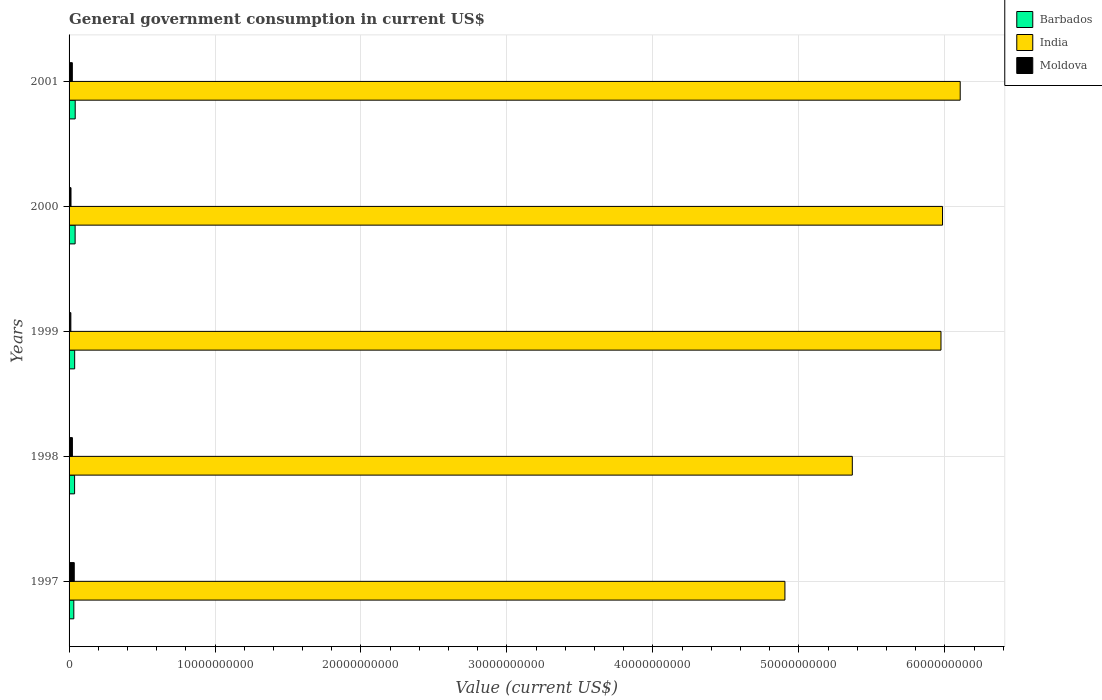How many different coloured bars are there?
Your answer should be very brief. 3. Are the number of bars on each tick of the Y-axis equal?
Make the answer very short. Yes. What is the label of the 3rd group of bars from the top?
Your response must be concise. 1999. What is the government conusmption in India in 1999?
Provide a short and direct response. 5.97e+1. Across all years, what is the maximum government conusmption in Barbados?
Make the answer very short. 4.20e+08. Across all years, what is the minimum government conusmption in Moldova?
Keep it short and to the point. 1.22e+08. In which year was the government conusmption in Moldova maximum?
Make the answer very short. 1997. In which year was the government conusmption in Moldova minimum?
Make the answer very short. 1999. What is the total government conusmption in India in the graph?
Your answer should be compact. 2.83e+11. What is the difference between the government conusmption in Barbados in 1998 and that in 2001?
Provide a short and direct response. -4.21e+07. What is the difference between the government conusmption in Moldova in 1998 and the government conusmption in Barbados in 2001?
Offer a very short reply. -1.92e+08. What is the average government conusmption in Barbados per year?
Provide a succinct answer. 3.84e+08. In the year 1999, what is the difference between the government conusmption in India and government conusmption in Moldova?
Your answer should be compact. 5.96e+1. What is the ratio of the government conusmption in Barbados in 2000 to that in 2001?
Your answer should be very brief. 0.99. Is the government conusmption in Moldova in 1997 less than that in 2000?
Your answer should be compact. No. What is the difference between the highest and the second highest government conusmption in Barbados?
Your response must be concise. 6.00e+06. What is the difference between the highest and the lowest government conusmption in Barbados?
Provide a succinct answer. 9.58e+07. In how many years, is the government conusmption in Barbados greater than the average government conusmption in Barbados taken over all years?
Provide a succinct answer. 2. Is the sum of the government conusmption in India in 1999 and 2000 greater than the maximum government conusmption in Barbados across all years?
Your answer should be very brief. Yes. What does the 2nd bar from the top in 1997 represents?
Offer a very short reply. India. What does the 2nd bar from the bottom in 2001 represents?
Your response must be concise. India. Are all the bars in the graph horizontal?
Make the answer very short. Yes. Does the graph contain any zero values?
Make the answer very short. No. Does the graph contain grids?
Keep it short and to the point. Yes. Where does the legend appear in the graph?
Keep it short and to the point. Top right. How many legend labels are there?
Offer a terse response. 3. How are the legend labels stacked?
Ensure brevity in your answer.  Vertical. What is the title of the graph?
Your answer should be compact. General government consumption in current US$. Does "Namibia" appear as one of the legend labels in the graph?
Your answer should be compact. No. What is the label or title of the X-axis?
Provide a short and direct response. Value (current US$). What is the label or title of the Y-axis?
Your answer should be compact. Years. What is the Value (current US$) in Barbados in 1997?
Provide a succinct answer. 3.25e+08. What is the Value (current US$) in India in 1997?
Offer a very short reply. 4.90e+1. What is the Value (current US$) in Moldova in 1997?
Make the answer very short. 3.55e+08. What is the Value (current US$) of Barbados in 1998?
Offer a very short reply. 3.78e+08. What is the Value (current US$) in India in 1998?
Make the answer very short. 5.37e+1. What is the Value (current US$) of Moldova in 1998?
Make the answer very short. 2.29e+08. What is the Value (current US$) of Barbados in 1999?
Your answer should be compact. 3.84e+08. What is the Value (current US$) of India in 1999?
Ensure brevity in your answer.  5.97e+1. What is the Value (current US$) of Moldova in 1999?
Give a very brief answer. 1.22e+08. What is the Value (current US$) of Barbados in 2000?
Provide a short and direct response. 4.14e+08. What is the Value (current US$) of India in 2000?
Offer a very short reply. 5.98e+1. What is the Value (current US$) in Moldova in 2000?
Provide a succinct answer. 1.32e+08. What is the Value (current US$) in Barbados in 2001?
Make the answer very short. 4.20e+08. What is the Value (current US$) in India in 2001?
Make the answer very short. 6.11e+1. What is the Value (current US$) in Moldova in 2001?
Your answer should be compact. 2.24e+08. Across all years, what is the maximum Value (current US$) of Barbados?
Offer a terse response. 4.20e+08. Across all years, what is the maximum Value (current US$) in India?
Provide a succinct answer. 6.11e+1. Across all years, what is the maximum Value (current US$) of Moldova?
Your response must be concise. 3.55e+08. Across all years, what is the minimum Value (current US$) of Barbados?
Offer a very short reply. 3.25e+08. Across all years, what is the minimum Value (current US$) in India?
Ensure brevity in your answer.  4.90e+1. Across all years, what is the minimum Value (current US$) of Moldova?
Provide a succinct answer. 1.22e+08. What is the total Value (current US$) of Barbados in the graph?
Make the answer very short. 1.92e+09. What is the total Value (current US$) of India in the graph?
Keep it short and to the point. 2.83e+11. What is the total Value (current US$) in Moldova in the graph?
Provide a succinct answer. 1.06e+09. What is the difference between the Value (current US$) of Barbados in 1997 and that in 1998?
Your answer should be very brief. -5.37e+07. What is the difference between the Value (current US$) in India in 1997 and that in 1998?
Provide a succinct answer. -4.62e+09. What is the difference between the Value (current US$) of Moldova in 1997 and that in 1998?
Your answer should be compact. 1.26e+08. What is the difference between the Value (current US$) of Barbados in 1997 and that in 1999?
Offer a terse response. -5.92e+07. What is the difference between the Value (current US$) in India in 1997 and that in 1999?
Your answer should be very brief. -1.07e+1. What is the difference between the Value (current US$) in Moldova in 1997 and that in 1999?
Provide a succinct answer. 2.33e+08. What is the difference between the Value (current US$) in Barbados in 1997 and that in 2000?
Keep it short and to the point. -8.98e+07. What is the difference between the Value (current US$) of India in 1997 and that in 2000?
Ensure brevity in your answer.  -1.08e+1. What is the difference between the Value (current US$) in Moldova in 1997 and that in 2000?
Provide a succinct answer. 2.22e+08. What is the difference between the Value (current US$) of Barbados in 1997 and that in 2001?
Provide a succinct answer. -9.58e+07. What is the difference between the Value (current US$) of India in 1997 and that in 2001?
Keep it short and to the point. -1.20e+1. What is the difference between the Value (current US$) of Moldova in 1997 and that in 2001?
Your answer should be very brief. 1.31e+08. What is the difference between the Value (current US$) in Barbados in 1998 and that in 1999?
Your answer should be compact. -5.47e+06. What is the difference between the Value (current US$) in India in 1998 and that in 1999?
Make the answer very short. -6.08e+09. What is the difference between the Value (current US$) of Moldova in 1998 and that in 1999?
Provide a succinct answer. 1.07e+08. What is the difference between the Value (current US$) in Barbados in 1998 and that in 2000?
Offer a terse response. -3.61e+07. What is the difference between the Value (current US$) in India in 1998 and that in 2000?
Provide a succinct answer. -6.18e+09. What is the difference between the Value (current US$) in Moldova in 1998 and that in 2000?
Ensure brevity in your answer.  9.66e+07. What is the difference between the Value (current US$) in Barbados in 1998 and that in 2001?
Ensure brevity in your answer.  -4.21e+07. What is the difference between the Value (current US$) of India in 1998 and that in 2001?
Keep it short and to the point. -7.39e+09. What is the difference between the Value (current US$) in Moldova in 1998 and that in 2001?
Give a very brief answer. 5.19e+06. What is the difference between the Value (current US$) of Barbados in 1999 and that in 2000?
Your answer should be very brief. -3.07e+07. What is the difference between the Value (current US$) in India in 1999 and that in 2000?
Provide a short and direct response. -1.06e+08. What is the difference between the Value (current US$) of Moldova in 1999 and that in 2000?
Give a very brief answer. -1.06e+07. What is the difference between the Value (current US$) of Barbados in 1999 and that in 2001?
Offer a terse response. -3.67e+07. What is the difference between the Value (current US$) of India in 1999 and that in 2001?
Make the answer very short. -1.32e+09. What is the difference between the Value (current US$) in Moldova in 1999 and that in 2001?
Your answer should be compact. -1.02e+08. What is the difference between the Value (current US$) in Barbados in 2000 and that in 2001?
Make the answer very short. -6.00e+06. What is the difference between the Value (current US$) in India in 2000 and that in 2001?
Make the answer very short. -1.21e+09. What is the difference between the Value (current US$) of Moldova in 2000 and that in 2001?
Ensure brevity in your answer.  -9.14e+07. What is the difference between the Value (current US$) of Barbados in 1997 and the Value (current US$) of India in 1998?
Provide a short and direct response. -5.33e+1. What is the difference between the Value (current US$) in Barbados in 1997 and the Value (current US$) in Moldova in 1998?
Your response must be concise. 9.58e+07. What is the difference between the Value (current US$) in India in 1997 and the Value (current US$) in Moldova in 1998?
Offer a very short reply. 4.88e+1. What is the difference between the Value (current US$) in Barbados in 1997 and the Value (current US$) in India in 1999?
Provide a short and direct response. -5.94e+1. What is the difference between the Value (current US$) of Barbados in 1997 and the Value (current US$) of Moldova in 1999?
Your response must be concise. 2.03e+08. What is the difference between the Value (current US$) in India in 1997 and the Value (current US$) in Moldova in 1999?
Your response must be concise. 4.89e+1. What is the difference between the Value (current US$) in Barbados in 1997 and the Value (current US$) in India in 2000?
Provide a short and direct response. -5.95e+1. What is the difference between the Value (current US$) of Barbados in 1997 and the Value (current US$) of Moldova in 2000?
Your response must be concise. 1.92e+08. What is the difference between the Value (current US$) in India in 1997 and the Value (current US$) in Moldova in 2000?
Ensure brevity in your answer.  4.89e+1. What is the difference between the Value (current US$) of Barbados in 1997 and the Value (current US$) of India in 2001?
Offer a terse response. -6.07e+1. What is the difference between the Value (current US$) in Barbados in 1997 and the Value (current US$) in Moldova in 2001?
Give a very brief answer. 1.01e+08. What is the difference between the Value (current US$) in India in 1997 and the Value (current US$) in Moldova in 2001?
Your response must be concise. 4.88e+1. What is the difference between the Value (current US$) of Barbados in 1998 and the Value (current US$) of India in 1999?
Keep it short and to the point. -5.94e+1. What is the difference between the Value (current US$) in Barbados in 1998 and the Value (current US$) in Moldova in 1999?
Give a very brief answer. 2.57e+08. What is the difference between the Value (current US$) of India in 1998 and the Value (current US$) of Moldova in 1999?
Your answer should be compact. 5.35e+1. What is the difference between the Value (current US$) in Barbados in 1998 and the Value (current US$) in India in 2000?
Provide a succinct answer. -5.95e+1. What is the difference between the Value (current US$) of Barbados in 1998 and the Value (current US$) of Moldova in 2000?
Give a very brief answer. 2.46e+08. What is the difference between the Value (current US$) in India in 1998 and the Value (current US$) in Moldova in 2000?
Your answer should be compact. 5.35e+1. What is the difference between the Value (current US$) of Barbados in 1998 and the Value (current US$) of India in 2001?
Your response must be concise. -6.07e+1. What is the difference between the Value (current US$) of Barbados in 1998 and the Value (current US$) of Moldova in 2001?
Your response must be concise. 1.55e+08. What is the difference between the Value (current US$) of India in 1998 and the Value (current US$) of Moldova in 2001?
Your response must be concise. 5.34e+1. What is the difference between the Value (current US$) of Barbados in 1999 and the Value (current US$) of India in 2000?
Ensure brevity in your answer.  -5.95e+1. What is the difference between the Value (current US$) of Barbados in 1999 and the Value (current US$) of Moldova in 2000?
Provide a short and direct response. 2.52e+08. What is the difference between the Value (current US$) of India in 1999 and the Value (current US$) of Moldova in 2000?
Give a very brief answer. 5.96e+1. What is the difference between the Value (current US$) in Barbados in 1999 and the Value (current US$) in India in 2001?
Offer a very short reply. -6.07e+1. What is the difference between the Value (current US$) in Barbados in 1999 and the Value (current US$) in Moldova in 2001?
Keep it short and to the point. 1.60e+08. What is the difference between the Value (current US$) of India in 1999 and the Value (current US$) of Moldova in 2001?
Make the answer very short. 5.95e+1. What is the difference between the Value (current US$) in Barbados in 2000 and the Value (current US$) in India in 2001?
Offer a very short reply. -6.06e+1. What is the difference between the Value (current US$) of Barbados in 2000 and the Value (current US$) of Moldova in 2001?
Offer a very short reply. 1.91e+08. What is the difference between the Value (current US$) in India in 2000 and the Value (current US$) in Moldova in 2001?
Your answer should be compact. 5.96e+1. What is the average Value (current US$) in Barbados per year?
Give a very brief answer. 3.84e+08. What is the average Value (current US$) of India per year?
Provide a succinct answer. 5.67e+1. What is the average Value (current US$) in Moldova per year?
Provide a succinct answer. 2.12e+08. In the year 1997, what is the difference between the Value (current US$) of Barbados and Value (current US$) of India?
Give a very brief answer. -4.87e+1. In the year 1997, what is the difference between the Value (current US$) of Barbados and Value (current US$) of Moldova?
Make the answer very short. -3.01e+07. In the year 1997, what is the difference between the Value (current US$) in India and Value (current US$) in Moldova?
Offer a very short reply. 4.87e+1. In the year 1998, what is the difference between the Value (current US$) in Barbados and Value (current US$) in India?
Offer a very short reply. -5.33e+1. In the year 1998, what is the difference between the Value (current US$) in Barbados and Value (current US$) in Moldova?
Provide a succinct answer. 1.49e+08. In the year 1998, what is the difference between the Value (current US$) of India and Value (current US$) of Moldova?
Your response must be concise. 5.34e+1. In the year 1999, what is the difference between the Value (current US$) in Barbados and Value (current US$) in India?
Offer a terse response. -5.94e+1. In the year 1999, what is the difference between the Value (current US$) of Barbados and Value (current US$) of Moldova?
Your answer should be very brief. 2.62e+08. In the year 1999, what is the difference between the Value (current US$) in India and Value (current US$) in Moldova?
Give a very brief answer. 5.96e+1. In the year 2000, what is the difference between the Value (current US$) in Barbados and Value (current US$) in India?
Provide a short and direct response. -5.94e+1. In the year 2000, what is the difference between the Value (current US$) of Barbados and Value (current US$) of Moldova?
Provide a short and direct response. 2.82e+08. In the year 2000, what is the difference between the Value (current US$) of India and Value (current US$) of Moldova?
Offer a terse response. 5.97e+1. In the year 2001, what is the difference between the Value (current US$) in Barbados and Value (current US$) in India?
Give a very brief answer. -6.06e+1. In the year 2001, what is the difference between the Value (current US$) in Barbados and Value (current US$) in Moldova?
Your response must be concise. 1.97e+08. In the year 2001, what is the difference between the Value (current US$) in India and Value (current US$) in Moldova?
Give a very brief answer. 6.08e+1. What is the ratio of the Value (current US$) of Barbados in 1997 to that in 1998?
Make the answer very short. 0.86. What is the ratio of the Value (current US$) in India in 1997 to that in 1998?
Offer a very short reply. 0.91. What is the ratio of the Value (current US$) of Moldova in 1997 to that in 1998?
Give a very brief answer. 1.55. What is the ratio of the Value (current US$) of Barbados in 1997 to that in 1999?
Keep it short and to the point. 0.85. What is the ratio of the Value (current US$) in India in 1997 to that in 1999?
Provide a succinct answer. 0.82. What is the ratio of the Value (current US$) in Moldova in 1997 to that in 1999?
Offer a terse response. 2.91. What is the ratio of the Value (current US$) in Barbados in 1997 to that in 2000?
Your response must be concise. 0.78. What is the ratio of the Value (current US$) in India in 1997 to that in 2000?
Provide a short and direct response. 0.82. What is the ratio of the Value (current US$) in Moldova in 1997 to that in 2000?
Your answer should be very brief. 2.68. What is the ratio of the Value (current US$) in Barbados in 1997 to that in 2001?
Keep it short and to the point. 0.77. What is the ratio of the Value (current US$) in India in 1997 to that in 2001?
Your answer should be very brief. 0.8. What is the ratio of the Value (current US$) of Moldova in 1997 to that in 2001?
Provide a short and direct response. 1.59. What is the ratio of the Value (current US$) in Barbados in 1998 to that in 1999?
Offer a terse response. 0.99. What is the ratio of the Value (current US$) of India in 1998 to that in 1999?
Your response must be concise. 0.9. What is the ratio of the Value (current US$) in Moldova in 1998 to that in 1999?
Provide a short and direct response. 1.88. What is the ratio of the Value (current US$) in Barbados in 1998 to that in 2000?
Offer a terse response. 0.91. What is the ratio of the Value (current US$) in India in 1998 to that in 2000?
Make the answer very short. 0.9. What is the ratio of the Value (current US$) of Moldova in 1998 to that in 2000?
Provide a short and direct response. 1.73. What is the ratio of the Value (current US$) in Barbados in 1998 to that in 2001?
Give a very brief answer. 0.9. What is the ratio of the Value (current US$) in India in 1998 to that in 2001?
Offer a terse response. 0.88. What is the ratio of the Value (current US$) of Moldova in 1998 to that in 2001?
Keep it short and to the point. 1.02. What is the ratio of the Value (current US$) in Barbados in 1999 to that in 2000?
Offer a terse response. 0.93. What is the ratio of the Value (current US$) in Moldova in 1999 to that in 2000?
Your response must be concise. 0.92. What is the ratio of the Value (current US$) of Barbados in 1999 to that in 2001?
Your answer should be compact. 0.91. What is the ratio of the Value (current US$) in India in 1999 to that in 2001?
Your answer should be compact. 0.98. What is the ratio of the Value (current US$) in Moldova in 1999 to that in 2001?
Give a very brief answer. 0.54. What is the ratio of the Value (current US$) in Barbados in 2000 to that in 2001?
Ensure brevity in your answer.  0.99. What is the ratio of the Value (current US$) of India in 2000 to that in 2001?
Give a very brief answer. 0.98. What is the ratio of the Value (current US$) in Moldova in 2000 to that in 2001?
Provide a short and direct response. 0.59. What is the difference between the highest and the second highest Value (current US$) of India?
Your answer should be very brief. 1.21e+09. What is the difference between the highest and the second highest Value (current US$) of Moldova?
Provide a short and direct response. 1.26e+08. What is the difference between the highest and the lowest Value (current US$) of Barbados?
Offer a terse response. 9.58e+07. What is the difference between the highest and the lowest Value (current US$) in India?
Your answer should be very brief. 1.20e+1. What is the difference between the highest and the lowest Value (current US$) of Moldova?
Your answer should be very brief. 2.33e+08. 